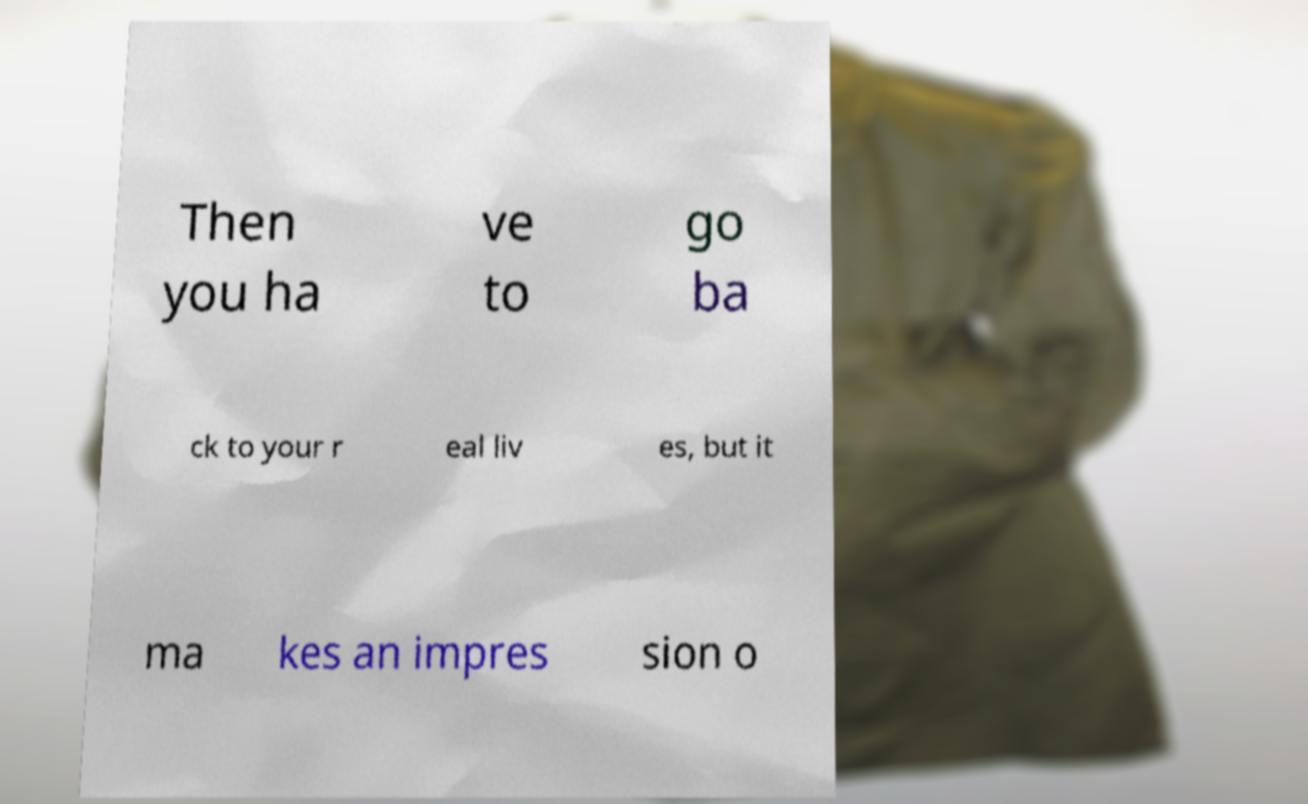Could you extract and type out the text from this image? Then you ha ve to go ba ck to your r eal liv es, but it ma kes an impres sion o 